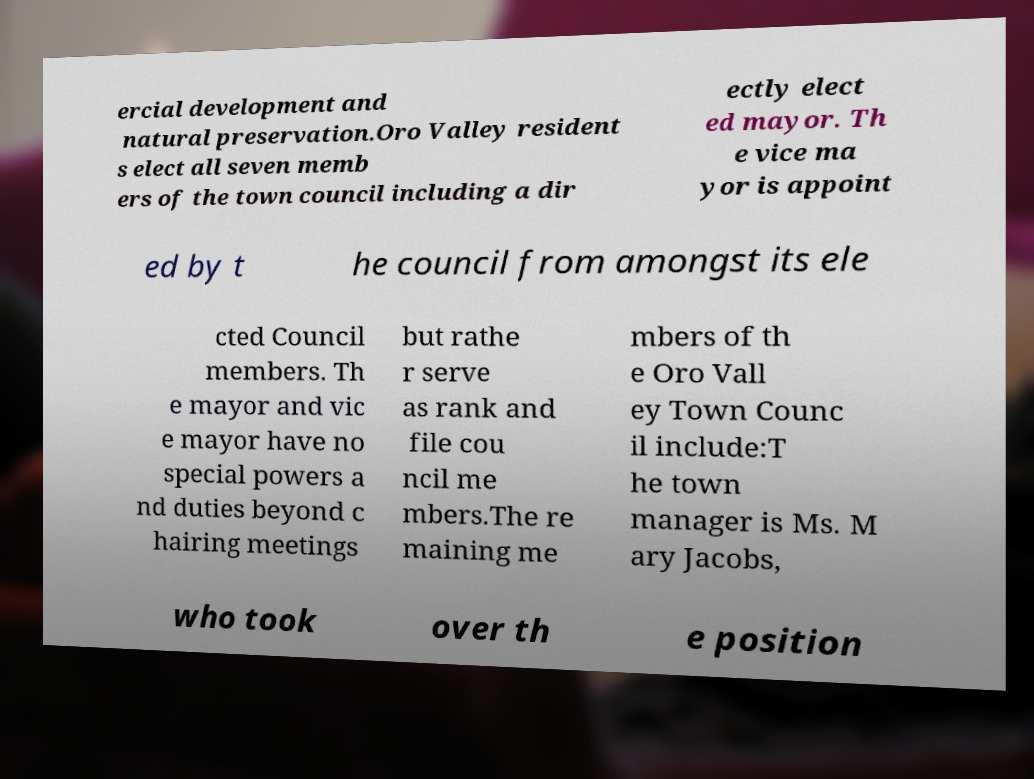For documentation purposes, I need the text within this image transcribed. Could you provide that? ercial development and natural preservation.Oro Valley resident s elect all seven memb ers of the town council including a dir ectly elect ed mayor. Th e vice ma yor is appoint ed by t he council from amongst its ele cted Council members. Th e mayor and vic e mayor have no special powers a nd duties beyond c hairing meetings but rathe r serve as rank and file cou ncil me mbers.The re maining me mbers of th e Oro Vall ey Town Counc il include:T he town manager is Ms. M ary Jacobs, who took over th e position 